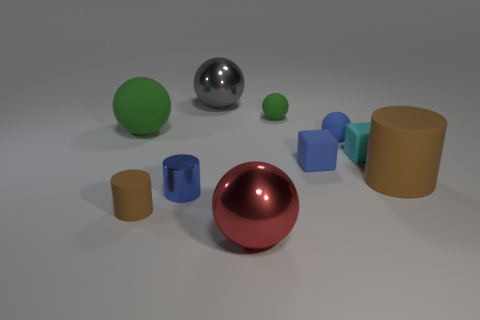Subtract all blue cubes. How many cubes are left? 1 Subtract all brown cylinders. How many cylinders are left? 1 Subtract all blocks. How many objects are left? 8 Subtract all small brown things. Subtract all metallic objects. How many objects are left? 6 Add 5 large green rubber things. How many large green rubber things are left? 6 Add 2 large green matte cylinders. How many large green matte cylinders exist? 2 Subtract 1 green balls. How many objects are left? 9 Subtract 2 cylinders. How many cylinders are left? 1 Subtract all gray cylinders. Subtract all gray balls. How many cylinders are left? 3 Subtract all green cylinders. How many brown balls are left? 0 